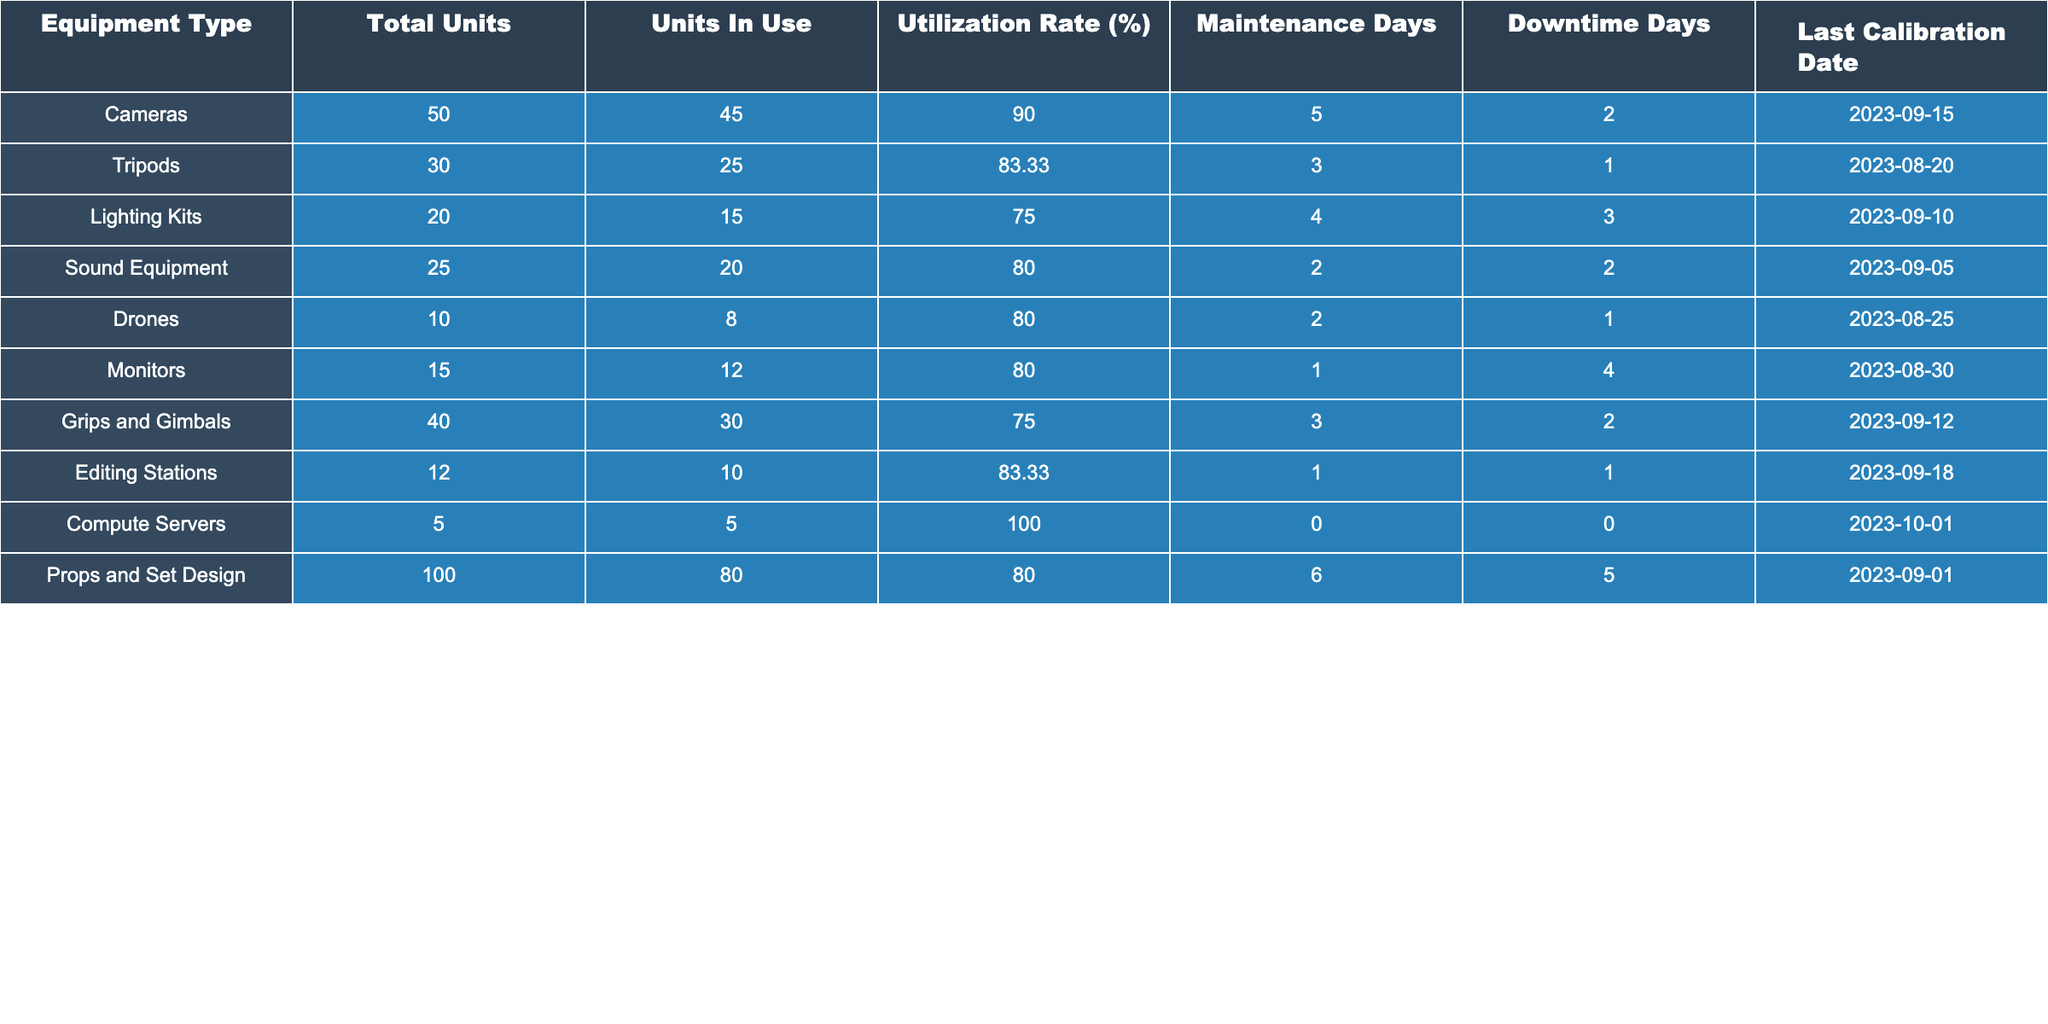What is the utilization rate of Drones? The utilization rate for Drones is directly listed in the table under "Utilization Rate (%)", which shows it to be 80%.
Answer: 80% How many total units of Lighting Kits are there? The total units of Lighting Kits is found in the "Total Units" column, which states there are 20 units.
Answer: 20 Which equipment type has the highest utilization rate? By comparing the "Utilization Rate (%)" values for all equipment types, Cameras has the highest rate at 90%.
Answer: Cameras What is the average utilization rate of all the equipment? First, sum the utilization rates: 90 + 83.33 + 75 + 80 + 80 + 80 + 75 + 83.33 + 100 + 80 = 828.66. Then divide by 10 (the number of equipment types): 828.66 / 10 = 82.87.
Answer: 82.87 Is the maintenance days for Tripods greater than the maintenance days for Sound Equipment? The table lists maintenance days as 3 for Tripods and 2 for Sound Equipment. Since 3 is greater than 2, the statement is true.
Answer: Yes How many units of Props and Set Design are not in use? There are 100 total units of Props and Set Design, with 80 units in use. Therefore, the unused units are 100 - 80 = 20.
Answer: 20 What is the difference in utilization rates between Cameras and Monitors? The utilization rate for Cameras is 90%, and for Monitors, it is 80%. To find the difference, calculate 90 - 80 = 10.
Answer: 10 Are the last calibration dates for Drones and Lighting Kits within the same month? The last calibration date for Drones is 2023-08-25, and for Lighting Kits, it is 2023-09-10. Since one is in August and the other in September, they are not within the same month.
Answer: No Which equipment type has the most downtime days? By comparing the "Downtime Days" for all equipment types, Props and Set Design has the highest with 5 downtime days.
Answer: Props and Set Design What is the total count of units in use for all equipment types combined? To find the total units in use, add all units in use: 45 + 25 + 15 + 20 + 8 + 12 + 30 + 10 + 5 + 80 = 250.
Answer: 250 